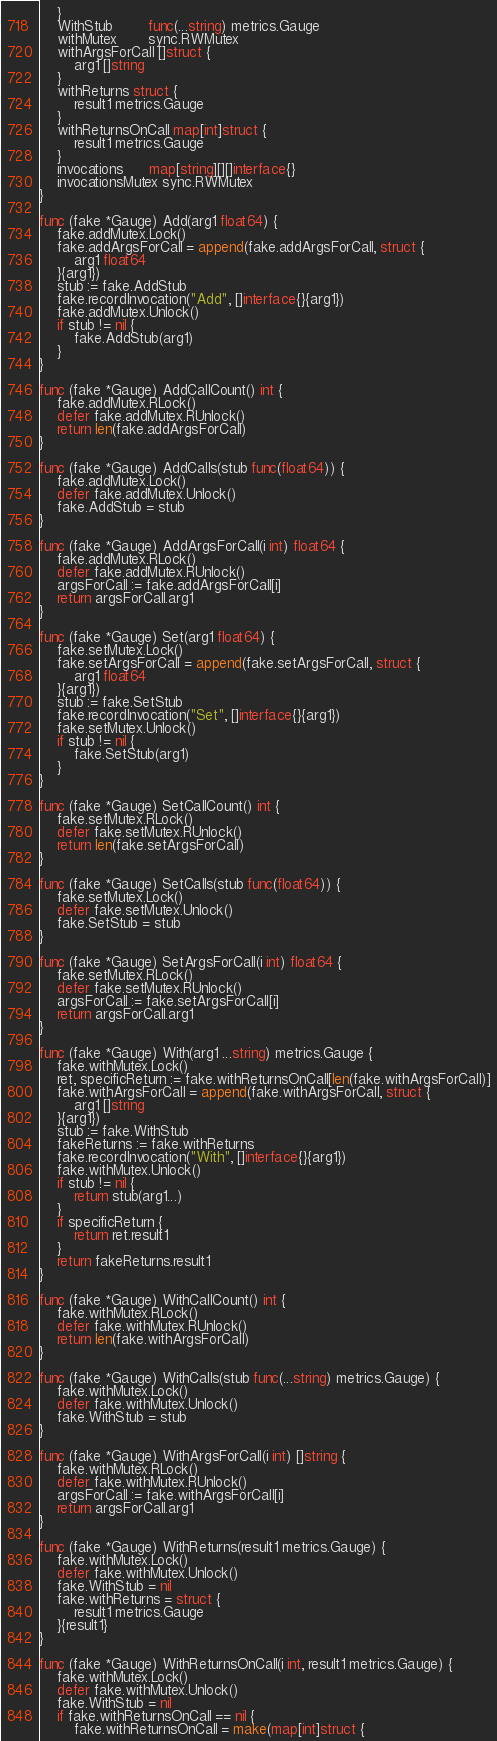<code> <loc_0><loc_0><loc_500><loc_500><_Go_>	}
	WithStub        func(...string) metrics.Gauge
	withMutex       sync.RWMutex
	withArgsForCall []struct {
		arg1 []string
	}
	withReturns struct {
		result1 metrics.Gauge
	}
	withReturnsOnCall map[int]struct {
		result1 metrics.Gauge
	}
	invocations      map[string][][]interface{}
	invocationsMutex sync.RWMutex
}

func (fake *Gauge) Add(arg1 float64) {
	fake.addMutex.Lock()
	fake.addArgsForCall = append(fake.addArgsForCall, struct {
		arg1 float64
	}{arg1})
	stub := fake.AddStub
	fake.recordInvocation("Add", []interface{}{arg1})
	fake.addMutex.Unlock()
	if stub != nil {
		fake.AddStub(arg1)
	}
}

func (fake *Gauge) AddCallCount() int {
	fake.addMutex.RLock()
	defer fake.addMutex.RUnlock()
	return len(fake.addArgsForCall)
}

func (fake *Gauge) AddCalls(stub func(float64)) {
	fake.addMutex.Lock()
	defer fake.addMutex.Unlock()
	fake.AddStub = stub
}

func (fake *Gauge) AddArgsForCall(i int) float64 {
	fake.addMutex.RLock()
	defer fake.addMutex.RUnlock()
	argsForCall := fake.addArgsForCall[i]
	return argsForCall.arg1
}

func (fake *Gauge) Set(arg1 float64) {
	fake.setMutex.Lock()
	fake.setArgsForCall = append(fake.setArgsForCall, struct {
		arg1 float64
	}{arg1})
	stub := fake.SetStub
	fake.recordInvocation("Set", []interface{}{arg1})
	fake.setMutex.Unlock()
	if stub != nil {
		fake.SetStub(arg1)
	}
}

func (fake *Gauge) SetCallCount() int {
	fake.setMutex.RLock()
	defer fake.setMutex.RUnlock()
	return len(fake.setArgsForCall)
}

func (fake *Gauge) SetCalls(stub func(float64)) {
	fake.setMutex.Lock()
	defer fake.setMutex.Unlock()
	fake.SetStub = stub
}

func (fake *Gauge) SetArgsForCall(i int) float64 {
	fake.setMutex.RLock()
	defer fake.setMutex.RUnlock()
	argsForCall := fake.setArgsForCall[i]
	return argsForCall.arg1
}

func (fake *Gauge) With(arg1 ...string) metrics.Gauge {
	fake.withMutex.Lock()
	ret, specificReturn := fake.withReturnsOnCall[len(fake.withArgsForCall)]
	fake.withArgsForCall = append(fake.withArgsForCall, struct {
		arg1 []string
	}{arg1})
	stub := fake.WithStub
	fakeReturns := fake.withReturns
	fake.recordInvocation("With", []interface{}{arg1})
	fake.withMutex.Unlock()
	if stub != nil {
		return stub(arg1...)
	}
	if specificReturn {
		return ret.result1
	}
	return fakeReturns.result1
}

func (fake *Gauge) WithCallCount() int {
	fake.withMutex.RLock()
	defer fake.withMutex.RUnlock()
	return len(fake.withArgsForCall)
}

func (fake *Gauge) WithCalls(stub func(...string) metrics.Gauge) {
	fake.withMutex.Lock()
	defer fake.withMutex.Unlock()
	fake.WithStub = stub
}

func (fake *Gauge) WithArgsForCall(i int) []string {
	fake.withMutex.RLock()
	defer fake.withMutex.RUnlock()
	argsForCall := fake.withArgsForCall[i]
	return argsForCall.arg1
}

func (fake *Gauge) WithReturns(result1 metrics.Gauge) {
	fake.withMutex.Lock()
	defer fake.withMutex.Unlock()
	fake.WithStub = nil
	fake.withReturns = struct {
		result1 metrics.Gauge
	}{result1}
}

func (fake *Gauge) WithReturnsOnCall(i int, result1 metrics.Gauge) {
	fake.withMutex.Lock()
	defer fake.withMutex.Unlock()
	fake.WithStub = nil
	if fake.withReturnsOnCall == nil {
		fake.withReturnsOnCall = make(map[int]struct {</code> 